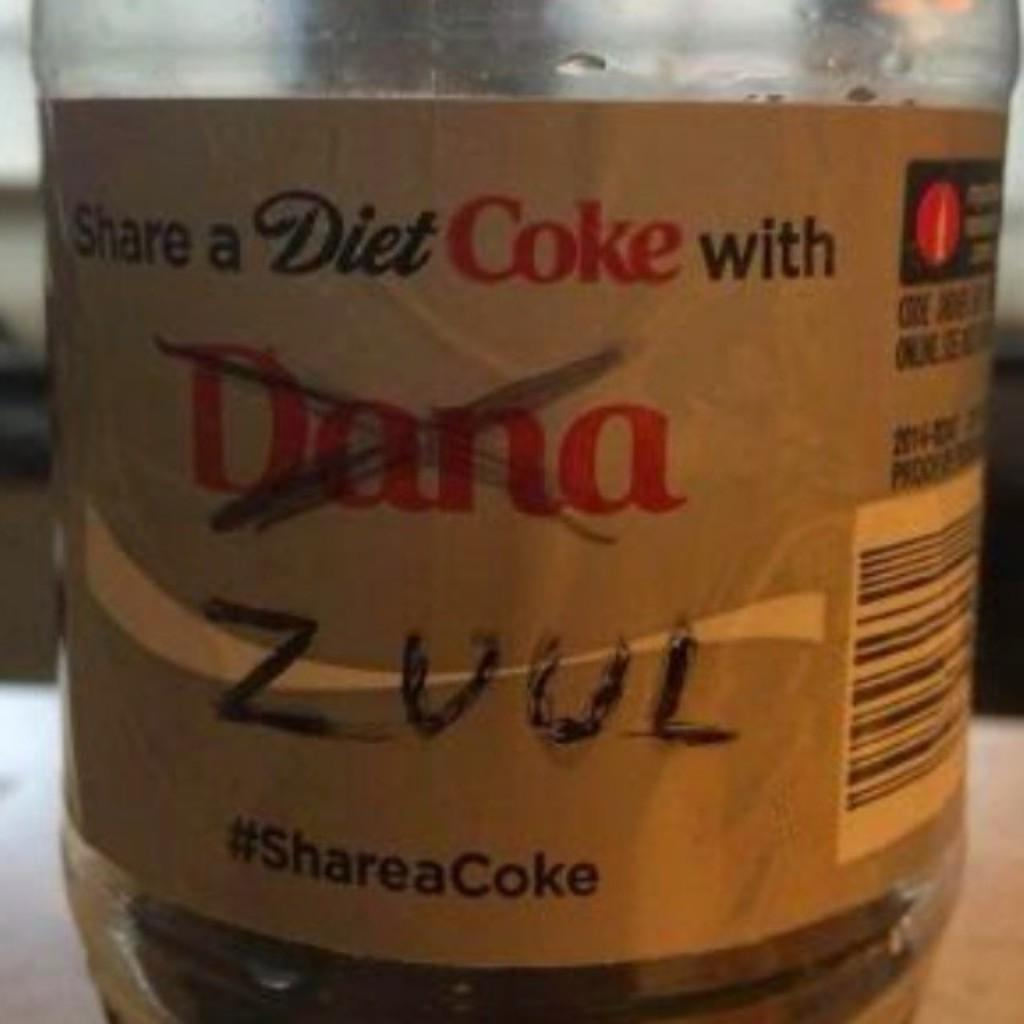<image>
Give a short and clear explanation of the subsequent image. Someone has crossed out the word "Dana" on a Diet Coke. 